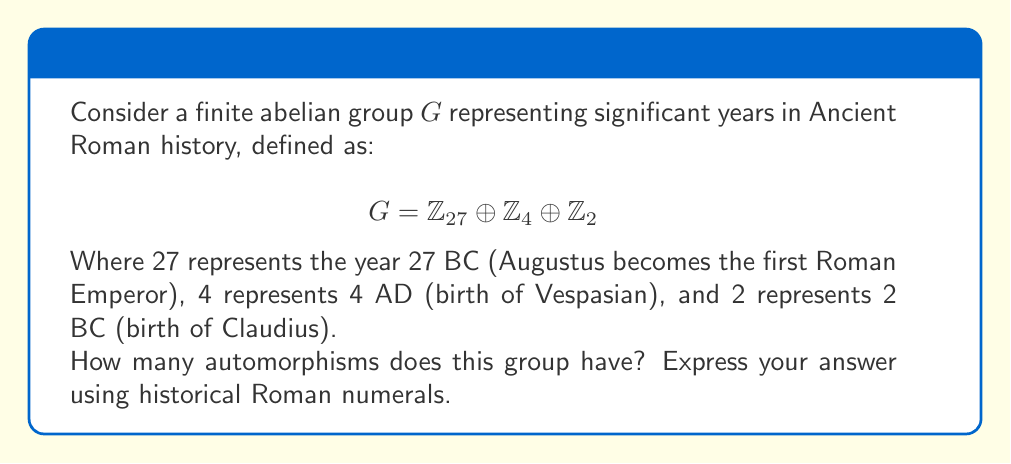Teach me how to tackle this problem. To find the number of automorphisms of the given finite abelian group, we'll follow these steps:

1) First, recall that for a finite abelian group $G = \mathbb{Z}_{n_1} \oplus \mathbb{Z}_{n_2} \oplus ... \oplus \mathbb{Z}_{n_k}$, the number of automorphisms is given by:

   $$|\text{Aut}(G)| = |\text{GL}(d_1, \mathbb{Z}_{p_1^{a_1}})| \cdot |\text{GL}(d_2, \mathbb{Z}_{p_2^{a_2}})| \cdot ... \cdot |\text{GL}(d_m, \mathbb{Z}_{p_m^{a_m}})|$$

   Where $p_i$ are distinct primes, $a_i$ are positive integers, and $d_i$ is the number of cyclic factors of order $p_i^{a_i}$.

2) In our case, $G = \mathbb{Z}_{27} \oplus \mathbb{Z}_4 \oplus \mathbb{Z}_2$

3) We can rewrite this as: $G = \mathbb{Z}_{3^3} \oplus \mathbb{Z}_{2^2} \oplus \mathbb{Z}_{2^1}$

4) So we have two prime factors: 3 and 2
   For 3: $d_1 = 1$, $p_1 = 3$, $a_1 = 3$
   For 2: $d_2 = 2$, $p_2 = 2$, $a_2 = 2$ (for $\mathbb{Z}_4$), and $a_3 = 1$ (for $\mathbb{Z}_2$)

5) Now we calculate:
   $|\text{GL}(1, \mathbb{Z}_{27})| = \phi(27) = 18$ (where $\phi$ is Euler's totient function)
   $|\text{GL}(2, \mathbb{Z}_4)| = |\text{GL}(2, \mathbb{Z}_2)| \cdot 2^4 = 6 \cdot 16 = 96$

6) Therefore, $|\text{Aut}(G)| = 18 \cdot 96 = 1728$

7) Convert 1728 to Roman numerals: MDCCXXVIII
Answer: MDCCXXVIII 